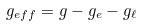<formula> <loc_0><loc_0><loc_500><loc_500>g _ { e f f } = g - g _ { e } - g _ { \ell }</formula> 